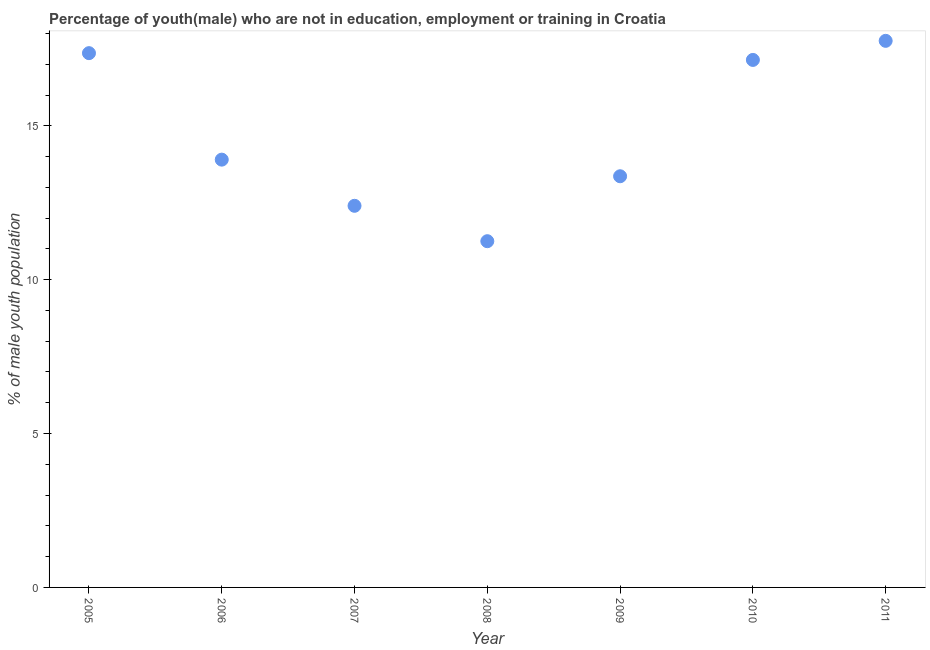What is the unemployed male youth population in 2005?
Keep it short and to the point. 17.36. Across all years, what is the maximum unemployed male youth population?
Provide a succinct answer. 17.76. Across all years, what is the minimum unemployed male youth population?
Provide a succinct answer. 11.25. What is the sum of the unemployed male youth population?
Your answer should be very brief. 103.17. What is the difference between the unemployed male youth population in 2006 and 2008?
Provide a succinct answer. 2.65. What is the average unemployed male youth population per year?
Provide a succinct answer. 14.74. What is the median unemployed male youth population?
Provide a succinct answer. 13.9. Do a majority of the years between 2009 and 2011 (inclusive) have unemployed male youth population greater than 2 %?
Your answer should be compact. Yes. What is the ratio of the unemployed male youth population in 2009 to that in 2011?
Your answer should be very brief. 0.75. Is the difference between the unemployed male youth population in 2008 and 2010 greater than the difference between any two years?
Provide a short and direct response. No. What is the difference between the highest and the second highest unemployed male youth population?
Your answer should be very brief. 0.4. What is the difference between the highest and the lowest unemployed male youth population?
Make the answer very short. 6.51. In how many years, is the unemployed male youth population greater than the average unemployed male youth population taken over all years?
Offer a terse response. 3. Does the unemployed male youth population monotonically increase over the years?
Your answer should be compact. No. How many years are there in the graph?
Offer a very short reply. 7. What is the difference between two consecutive major ticks on the Y-axis?
Provide a succinct answer. 5. Does the graph contain grids?
Your response must be concise. No. What is the title of the graph?
Give a very brief answer. Percentage of youth(male) who are not in education, employment or training in Croatia. What is the label or title of the Y-axis?
Ensure brevity in your answer.  % of male youth population. What is the % of male youth population in 2005?
Your answer should be very brief. 17.36. What is the % of male youth population in 2006?
Provide a succinct answer. 13.9. What is the % of male youth population in 2007?
Provide a short and direct response. 12.4. What is the % of male youth population in 2008?
Ensure brevity in your answer.  11.25. What is the % of male youth population in 2009?
Your response must be concise. 13.36. What is the % of male youth population in 2010?
Give a very brief answer. 17.14. What is the % of male youth population in 2011?
Give a very brief answer. 17.76. What is the difference between the % of male youth population in 2005 and 2006?
Make the answer very short. 3.46. What is the difference between the % of male youth population in 2005 and 2007?
Offer a terse response. 4.96. What is the difference between the % of male youth population in 2005 and 2008?
Keep it short and to the point. 6.11. What is the difference between the % of male youth population in 2005 and 2009?
Your answer should be very brief. 4. What is the difference between the % of male youth population in 2005 and 2010?
Make the answer very short. 0.22. What is the difference between the % of male youth population in 2005 and 2011?
Provide a short and direct response. -0.4. What is the difference between the % of male youth population in 2006 and 2007?
Make the answer very short. 1.5. What is the difference between the % of male youth population in 2006 and 2008?
Offer a terse response. 2.65. What is the difference between the % of male youth population in 2006 and 2009?
Make the answer very short. 0.54. What is the difference between the % of male youth population in 2006 and 2010?
Provide a succinct answer. -3.24. What is the difference between the % of male youth population in 2006 and 2011?
Ensure brevity in your answer.  -3.86. What is the difference between the % of male youth population in 2007 and 2008?
Provide a short and direct response. 1.15. What is the difference between the % of male youth population in 2007 and 2009?
Your answer should be compact. -0.96. What is the difference between the % of male youth population in 2007 and 2010?
Make the answer very short. -4.74. What is the difference between the % of male youth population in 2007 and 2011?
Your answer should be very brief. -5.36. What is the difference between the % of male youth population in 2008 and 2009?
Offer a terse response. -2.11. What is the difference between the % of male youth population in 2008 and 2010?
Your answer should be very brief. -5.89. What is the difference between the % of male youth population in 2008 and 2011?
Give a very brief answer. -6.51. What is the difference between the % of male youth population in 2009 and 2010?
Provide a short and direct response. -3.78. What is the difference between the % of male youth population in 2010 and 2011?
Give a very brief answer. -0.62. What is the ratio of the % of male youth population in 2005 to that in 2006?
Your response must be concise. 1.25. What is the ratio of the % of male youth population in 2005 to that in 2008?
Offer a very short reply. 1.54. What is the ratio of the % of male youth population in 2005 to that in 2009?
Your answer should be compact. 1.3. What is the ratio of the % of male youth population in 2005 to that in 2011?
Make the answer very short. 0.98. What is the ratio of the % of male youth population in 2006 to that in 2007?
Give a very brief answer. 1.12. What is the ratio of the % of male youth population in 2006 to that in 2008?
Your answer should be compact. 1.24. What is the ratio of the % of male youth population in 2006 to that in 2009?
Provide a short and direct response. 1.04. What is the ratio of the % of male youth population in 2006 to that in 2010?
Your answer should be very brief. 0.81. What is the ratio of the % of male youth population in 2006 to that in 2011?
Ensure brevity in your answer.  0.78. What is the ratio of the % of male youth population in 2007 to that in 2008?
Offer a terse response. 1.1. What is the ratio of the % of male youth population in 2007 to that in 2009?
Give a very brief answer. 0.93. What is the ratio of the % of male youth population in 2007 to that in 2010?
Offer a very short reply. 0.72. What is the ratio of the % of male youth population in 2007 to that in 2011?
Make the answer very short. 0.7. What is the ratio of the % of male youth population in 2008 to that in 2009?
Provide a succinct answer. 0.84. What is the ratio of the % of male youth population in 2008 to that in 2010?
Your answer should be compact. 0.66. What is the ratio of the % of male youth population in 2008 to that in 2011?
Give a very brief answer. 0.63. What is the ratio of the % of male youth population in 2009 to that in 2010?
Your answer should be very brief. 0.78. What is the ratio of the % of male youth population in 2009 to that in 2011?
Provide a succinct answer. 0.75. 